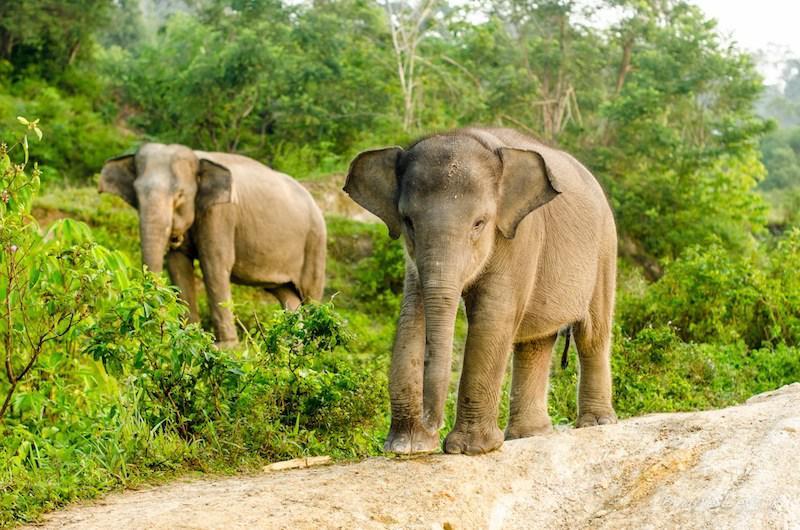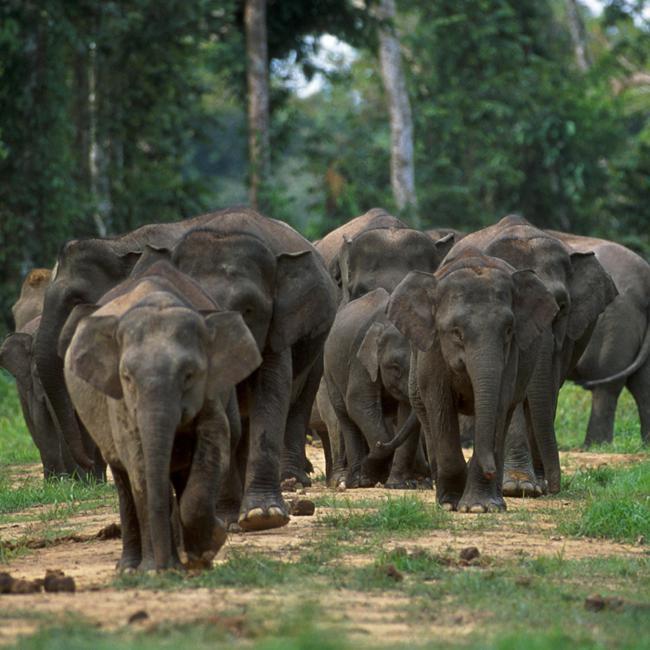The first image is the image on the left, the second image is the image on the right. For the images shown, is this caption "There are at leasts six elephants in one image." true? Answer yes or no. Yes. The first image is the image on the left, the second image is the image on the right. Examine the images to the left and right. Is the description "there are two elephants in the left side pic" accurate? Answer yes or no. Yes. 